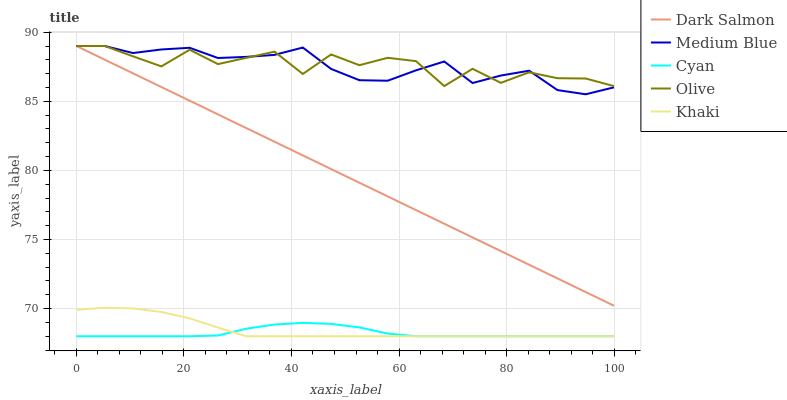Does Cyan have the minimum area under the curve?
Answer yes or no. Yes. Does Olive have the maximum area under the curve?
Answer yes or no. Yes. Does Khaki have the minimum area under the curve?
Answer yes or no. No. Does Khaki have the maximum area under the curve?
Answer yes or no. No. Is Dark Salmon the smoothest?
Answer yes or no. Yes. Is Olive the roughest?
Answer yes or no. Yes. Is Cyan the smoothest?
Answer yes or no. No. Is Cyan the roughest?
Answer yes or no. No. Does Cyan have the lowest value?
Answer yes or no. Yes. Does Medium Blue have the lowest value?
Answer yes or no. No. Does Dark Salmon have the highest value?
Answer yes or no. Yes. Does Khaki have the highest value?
Answer yes or no. No. Is Khaki less than Medium Blue?
Answer yes or no. Yes. Is Olive greater than Khaki?
Answer yes or no. Yes. Does Medium Blue intersect Dark Salmon?
Answer yes or no. Yes. Is Medium Blue less than Dark Salmon?
Answer yes or no. No. Is Medium Blue greater than Dark Salmon?
Answer yes or no. No. Does Khaki intersect Medium Blue?
Answer yes or no. No. 